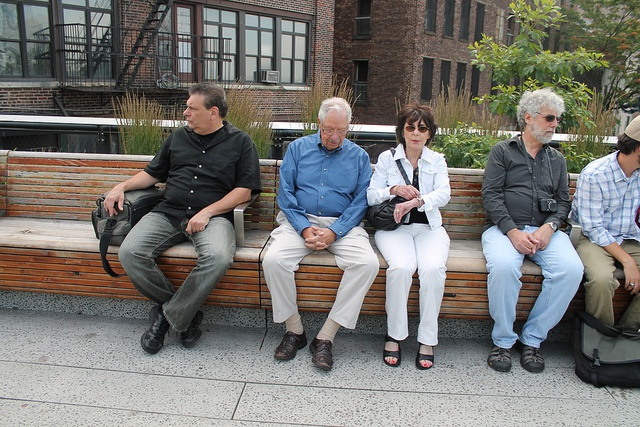Describe the objects in this image and their specific colors. I can see people in black, gray, and darkgray tones, bench in black, brown, darkgray, gray, and maroon tones, people in black, gray, lightblue, and lavender tones, people in black, darkgray, lightgray, and gray tones, and people in black, lavender, darkgray, and gray tones in this image. 